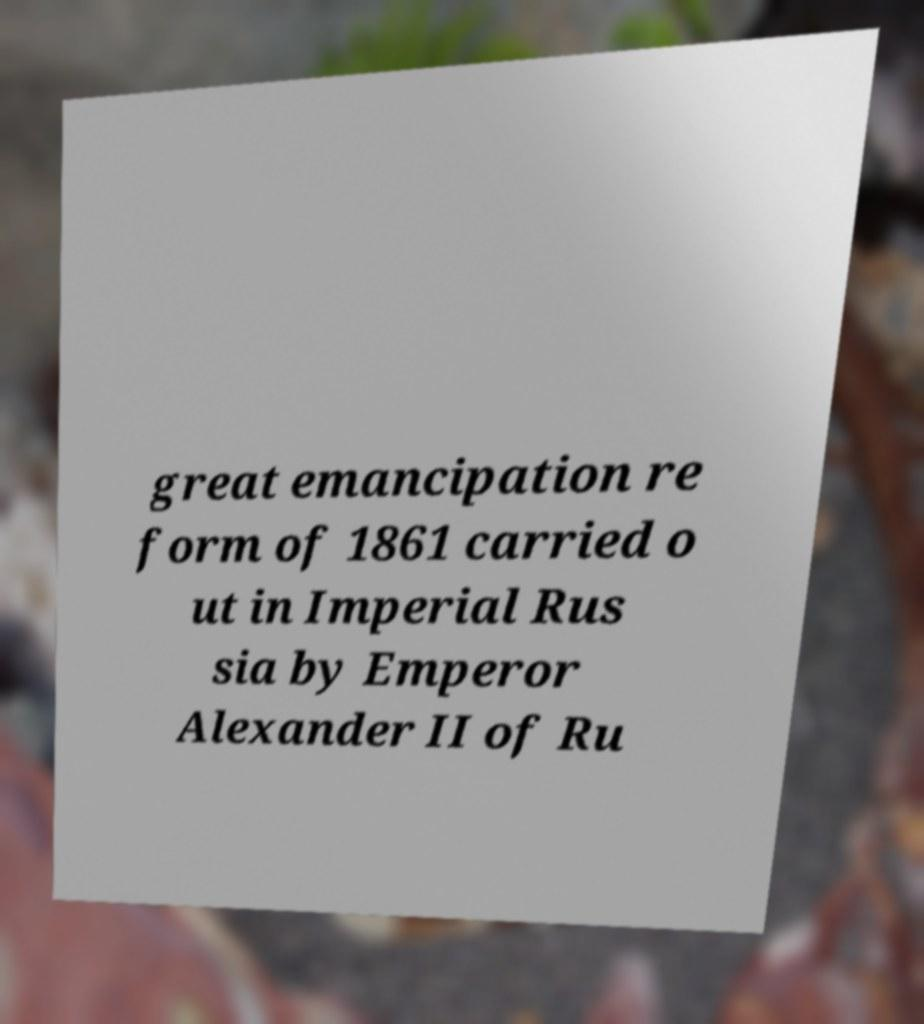Please read and relay the text visible in this image. What does it say? great emancipation re form of 1861 carried o ut in Imperial Rus sia by Emperor Alexander II of Ru 